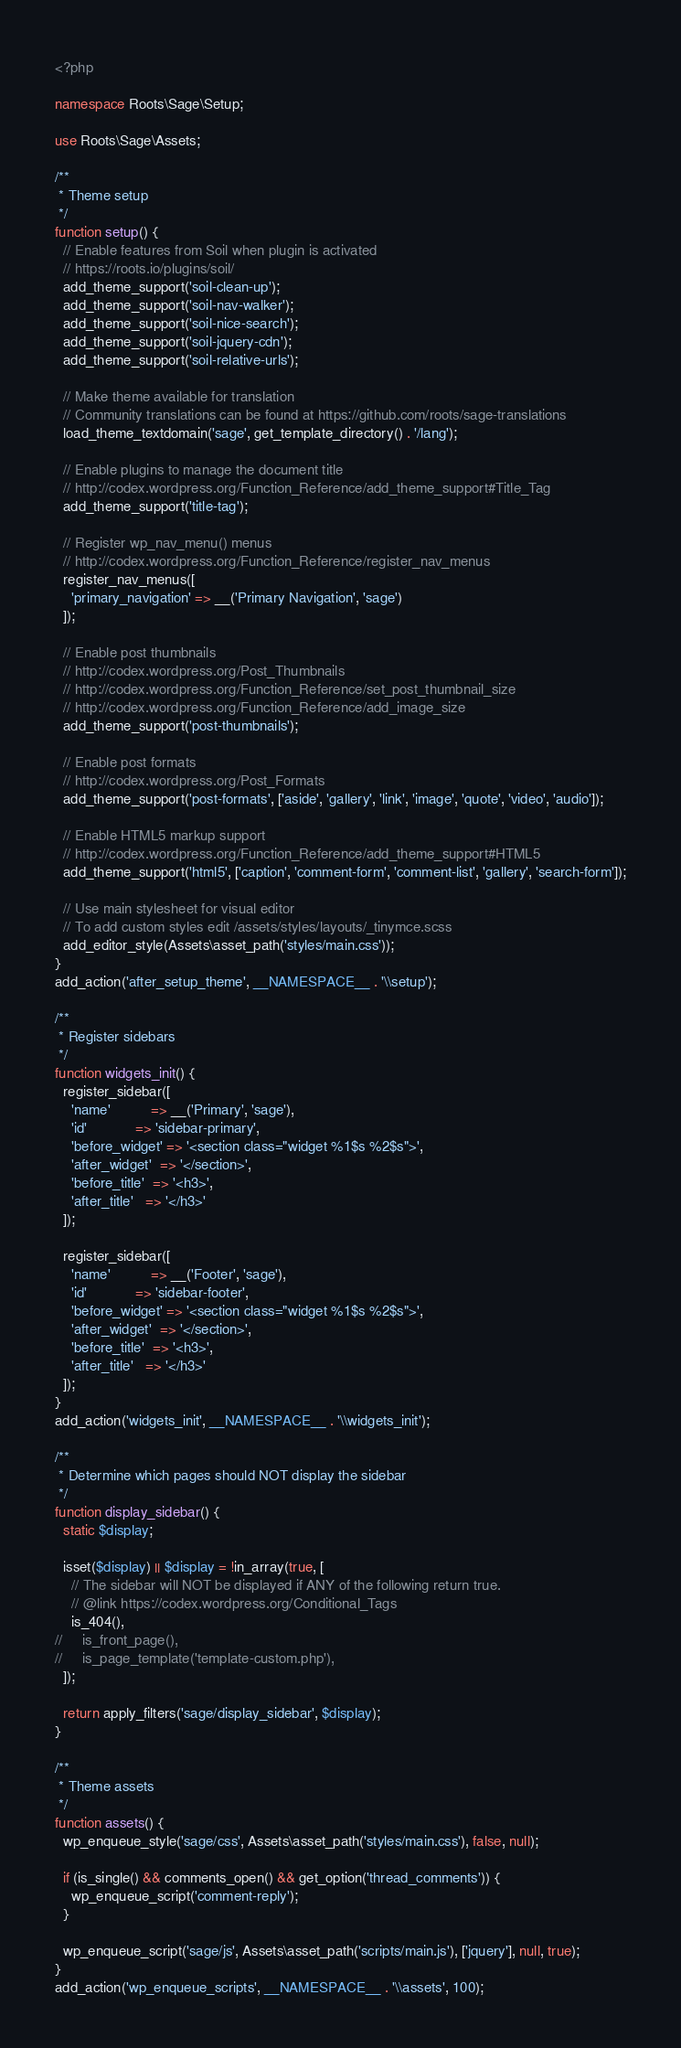<code> <loc_0><loc_0><loc_500><loc_500><_PHP_><?php

namespace Roots\Sage\Setup;

use Roots\Sage\Assets;

/**
 * Theme setup
 */
function setup() {
  // Enable features from Soil when plugin is activated
  // https://roots.io/plugins/soil/
  add_theme_support('soil-clean-up');
  add_theme_support('soil-nav-walker');
  add_theme_support('soil-nice-search');
  add_theme_support('soil-jquery-cdn');
  add_theme_support('soil-relative-urls');

  // Make theme available for translation
  // Community translations can be found at https://github.com/roots/sage-translations
  load_theme_textdomain('sage', get_template_directory() . '/lang');

  // Enable plugins to manage the document title
  // http://codex.wordpress.org/Function_Reference/add_theme_support#Title_Tag
  add_theme_support('title-tag');

  // Register wp_nav_menu() menus
  // http://codex.wordpress.org/Function_Reference/register_nav_menus
  register_nav_menus([
    'primary_navigation' => __('Primary Navigation', 'sage')
  ]);

  // Enable post thumbnails
  // http://codex.wordpress.org/Post_Thumbnails
  // http://codex.wordpress.org/Function_Reference/set_post_thumbnail_size
  // http://codex.wordpress.org/Function_Reference/add_image_size
  add_theme_support('post-thumbnails');

  // Enable post formats
  // http://codex.wordpress.org/Post_Formats
  add_theme_support('post-formats', ['aside', 'gallery', 'link', 'image', 'quote', 'video', 'audio']);

  // Enable HTML5 markup support
  // http://codex.wordpress.org/Function_Reference/add_theme_support#HTML5
  add_theme_support('html5', ['caption', 'comment-form', 'comment-list', 'gallery', 'search-form']);

  // Use main stylesheet for visual editor
  // To add custom styles edit /assets/styles/layouts/_tinymce.scss
  add_editor_style(Assets\asset_path('styles/main.css'));
}
add_action('after_setup_theme', __NAMESPACE__ . '\\setup');

/**
 * Register sidebars
 */
function widgets_init() {
  register_sidebar([
    'name'          => __('Primary', 'sage'),
    'id'            => 'sidebar-primary',
    'before_widget' => '<section class="widget %1$s %2$s">',
    'after_widget'  => '</section>',
    'before_title'  => '<h3>',
    'after_title'   => '</h3>'
  ]);

  register_sidebar([
    'name'          => __('Footer', 'sage'),
    'id'            => 'sidebar-footer',
    'before_widget' => '<section class="widget %1$s %2$s">',
    'after_widget'  => '</section>',
    'before_title'  => '<h3>',
    'after_title'   => '</h3>'
  ]);
}
add_action('widgets_init', __NAMESPACE__ . '\\widgets_init');

/**
 * Determine which pages should NOT display the sidebar
 */
function display_sidebar() {
  static $display;

  isset($display) || $display = !in_array(true, [
    // The sidebar will NOT be displayed if ANY of the following return true.
    // @link https://codex.wordpress.org/Conditional_Tags
    is_404(),
//     is_front_page(),
//     is_page_template('template-custom.php'),
  ]);

  return apply_filters('sage/display_sidebar', $display);
}

/**
 * Theme assets
 */
function assets() {
  wp_enqueue_style('sage/css', Assets\asset_path('styles/main.css'), false, null);

  if (is_single() && comments_open() && get_option('thread_comments')) {
    wp_enqueue_script('comment-reply');
  }

  wp_enqueue_script('sage/js', Assets\asset_path('scripts/main.js'), ['jquery'], null, true);
}
add_action('wp_enqueue_scripts', __NAMESPACE__ . '\\assets', 100);
</code> 